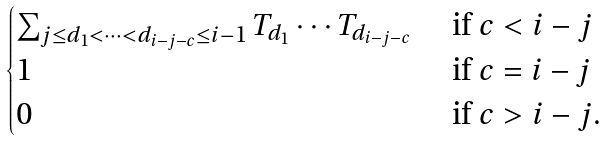<formula> <loc_0><loc_0><loc_500><loc_500>\begin{cases} \sum _ { j \leq d _ { 1 } < \cdots < d _ { i - j - c } \leq i - 1 } T _ { d _ { 1 } } \cdots T _ { d _ { i - j - c } } & \text { if } c < i - j \\ 1 & \text { if } c = i - j \\ 0 & \text { if } c > i - j . \end{cases}</formula> 